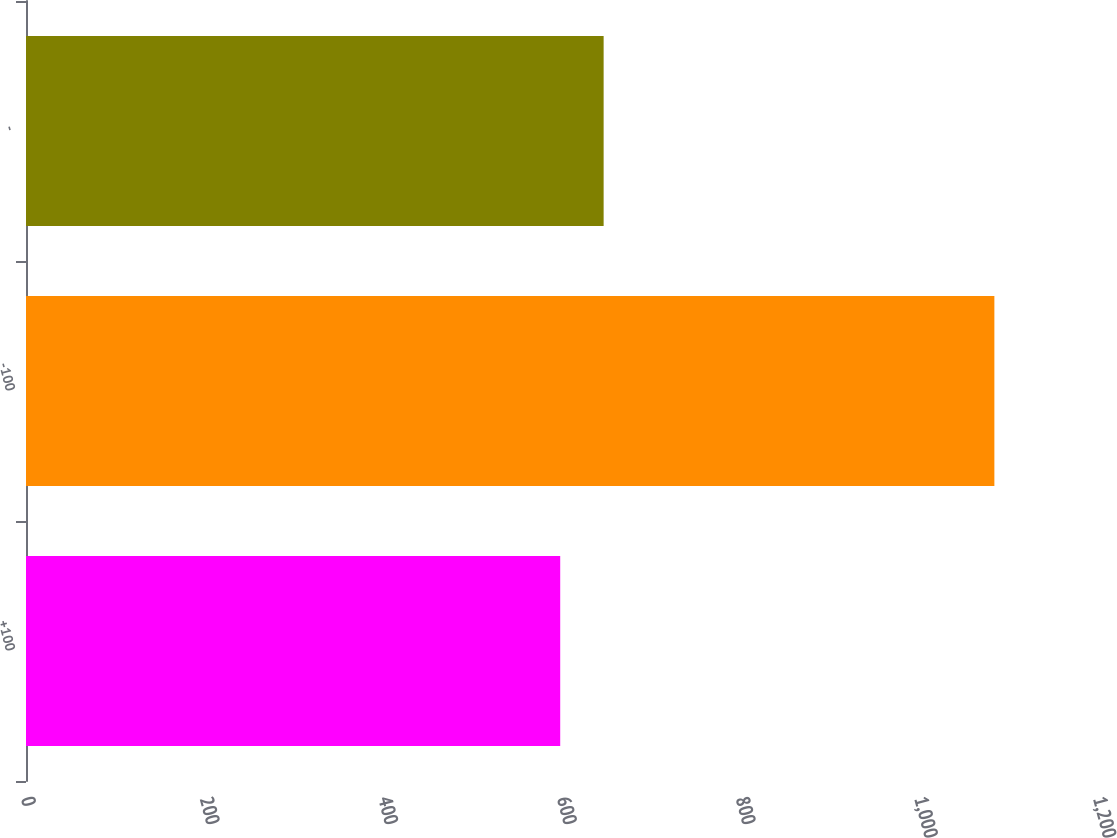Convert chart. <chart><loc_0><loc_0><loc_500><loc_500><bar_chart><fcel>+100<fcel>-100<fcel>-<nl><fcel>598<fcel>1084<fcel>646.6<nl></chart> 